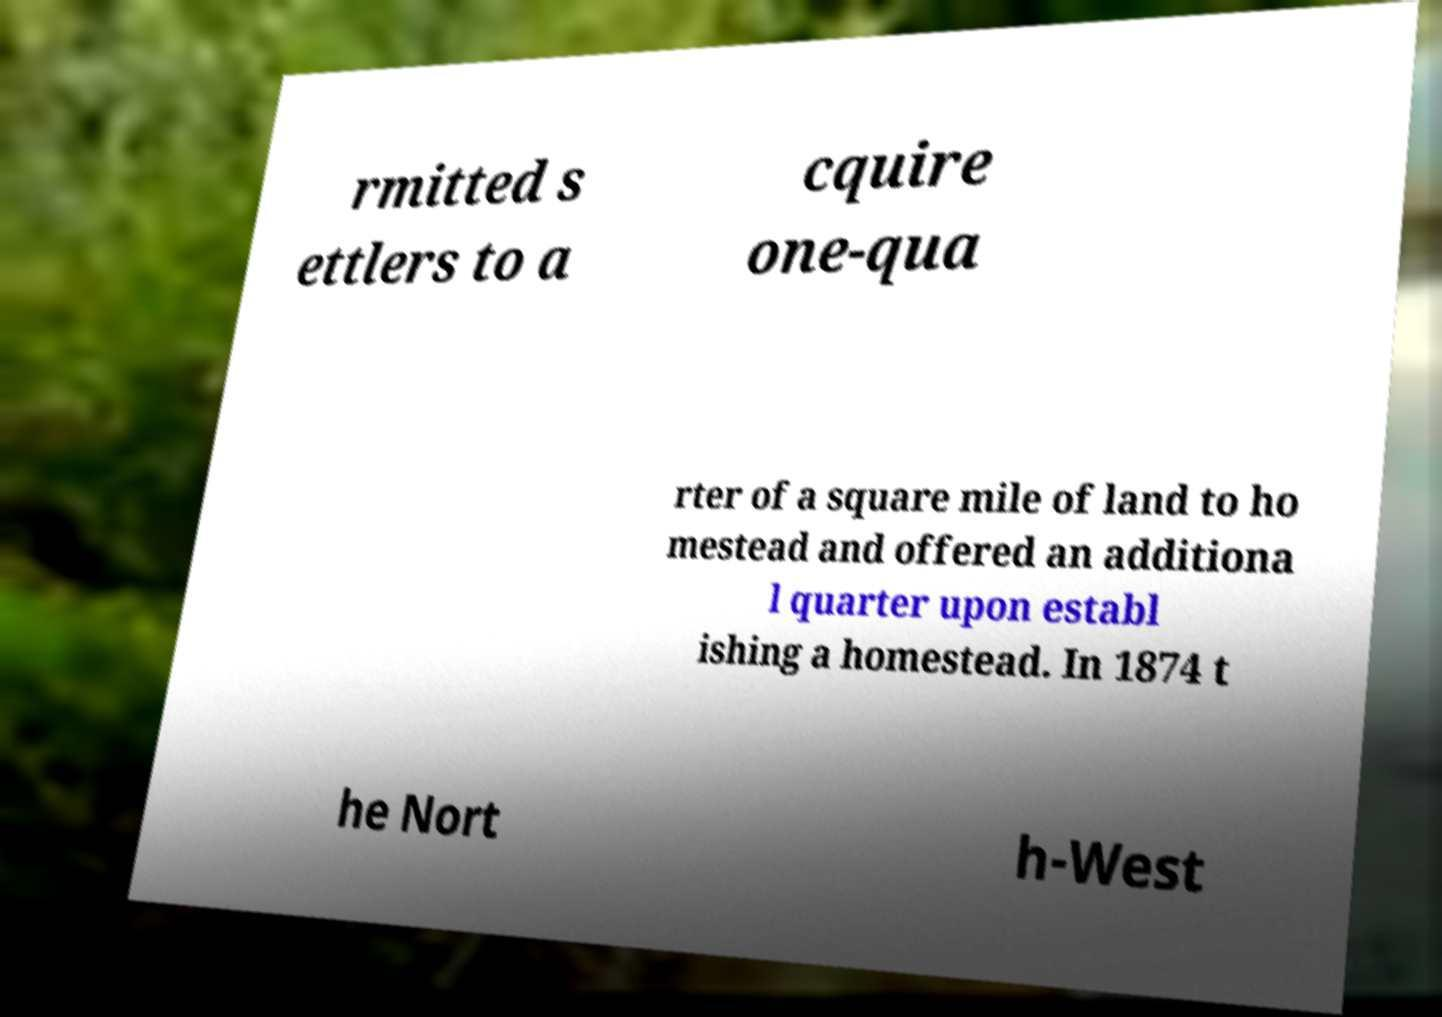Could you assist in decoding the text presented in this image and type it out clearly? rmitted s ettlers to a cquire one-qua rter of a square mile of land to ho mestead and offered an additiona l quarter upon establ ishing a homestead. In 1874 t he Nort h-West 